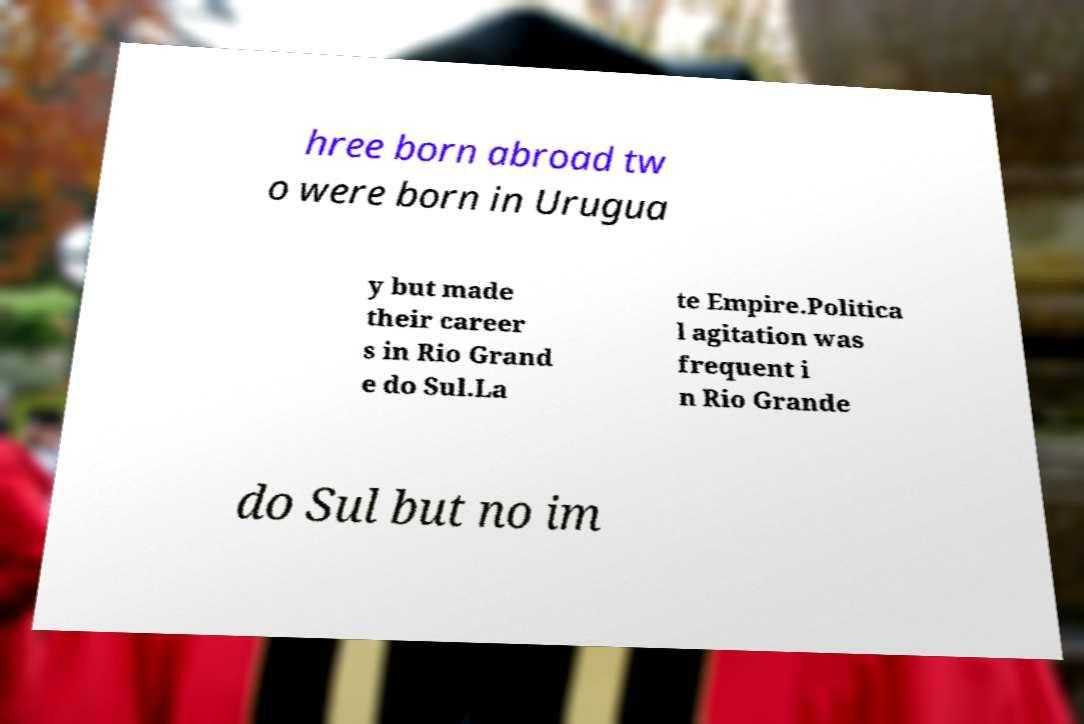Please identify and transcribe the text found in this image. hree born abroad tw o were born in Urugua y but made their career s in Rio Grand e do Sul.La te Empire.Politica l agitation was frequent i n Rio Grande do Sul but no im 